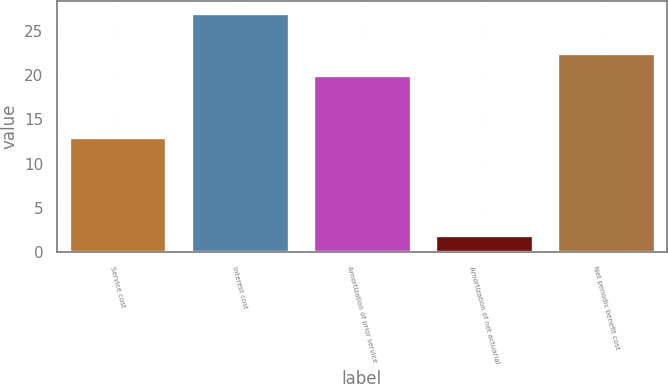Convert chart. <chart><loc_0><loc_0><loc_500><loc_500><bar_chart><fcel>Service cost<fcel>Interest cost<fcel>Amortization of prior service<fcel>Amortization of net actuarial<fcel>Net periodic benefit cost<nl><fcel>13<fcel>27<fcel>20<fcel>2<fcel>22.5<nl></chart> 